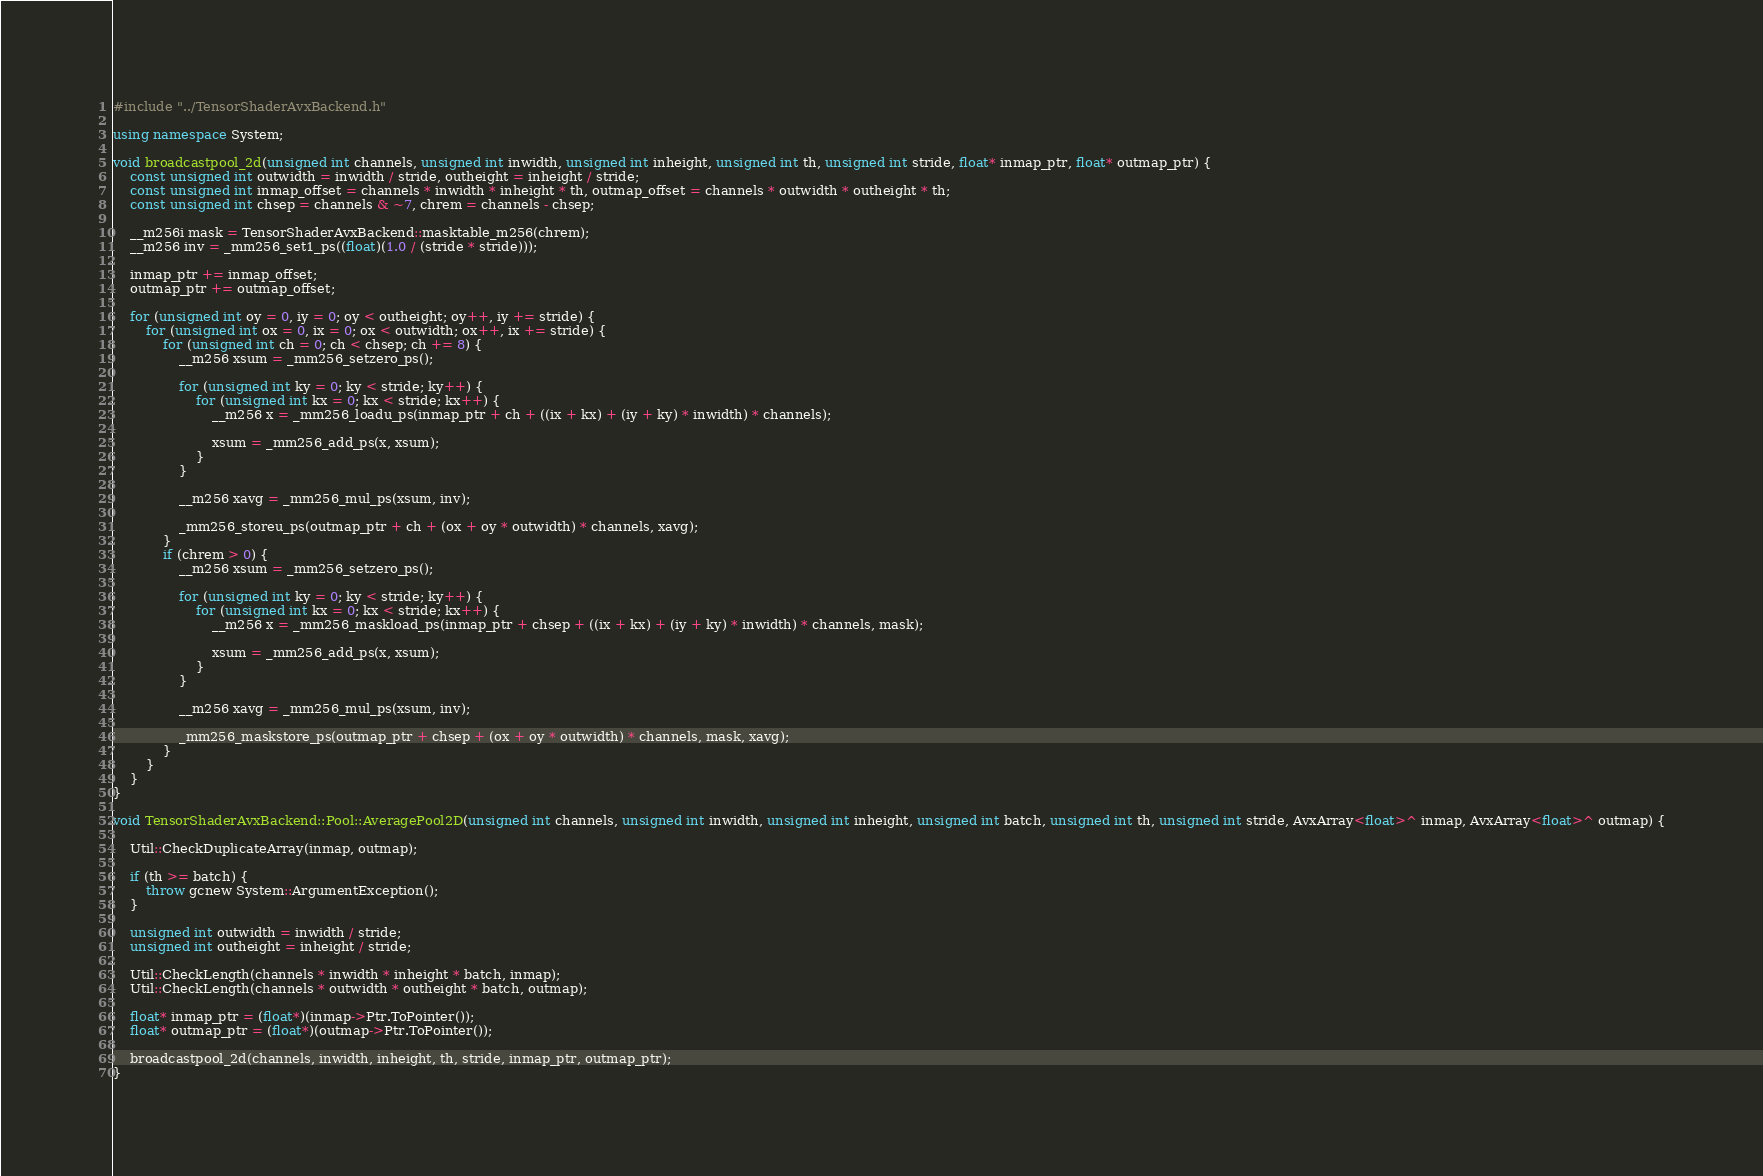<code> <loc_0><loc_0><loc_500><loc_500><_C++_>#include "../TensorShaderAvxBackend.h"

using namespace System;

void broadcastpool_2d(unsigned int channels, unsigned int inwidth, unsigned int inheight, unsigned int th, unsigned int stride, float* inmap_ptr, float* outmap_ptr) {
    const unsigned int outwidth = inwidth / stride, outheight = inheight / stride;
    const unsigned int inmap_offset = channels * inwidth * inheight * th, outmap_offset = channels * outwidth * outheight * th;
    const unsigned int chsep = channels & ~7, chrem = channels - chsep;

    __m256i mask = TensorShaderAvxBackend::masktable_m256(chrem);
    __m256 inv = _mm256_set1_ps((float)(1.0 / (stride * stride)));

    inmap_ptr += inmap_offset;
    outmap_ptr += outmap_offset;

    for (unsigned int oy = 0, iy = 0; oy < outheight; oy++, iy += stride) {
        for (unsigned int ox = 0, ix = 0; ox < outwidth; ox++, ix += stride) {
            for (unsigned int ch = 0; ch < chsep; ch += 8) {
                __m256 xsum = _mm256_setzero_ps();

                for (unsigned int ky = 0; ky < stride; ky++) {
                    for (unsigned int kx = 0; kx < stride; kx++) {
                        __m256 x = _mm256_loadu_ps(inmap_ptr + ch + ((ix + kx) + (iy + ky) * inwidth) * channels);

                        xsum = _mm256_add_ps(x, xsum);
                    }
                }

                __m256 xavg = _mm256_mul_ps(xsum, inv);

                _mm256_storeu_ps(outmap_ptr + ch + (ox + oy * outwidth) * channels, xavg);
            }
            if (chrem > 0) {
                __m256 xsum = _mm256_setzero_ps();

                for (unsigned int ky = 0; ky < stride; ky++) {
                    for (unsigned int kx = 0; kx < stride; kx++) {
                        __m256 x = _mm256_maskload_ps(inmap_ptr + chsep + ((ix + kx) + (iy + ky) * inwidth) * channels, mask);

                        xsum = _mm256_add_ps(x, xsum);
                    }
                }

                __m256 xavg = _mm256_mul_ps(xsum, inv);

                _mm256_maskstore_ps(outmap_ptr + chsep + (ox + oy * outwidth) * channels, mask, xavg);
            }
        }
    }
}

void TensorShaderAvxBackend::Pool::AveragePool2D(unsigned int channels, unsigned int inwidth, unsigned int inheight, unsigned int batch, unsigned int th, unsigned int stride, AvxArray<float>^ inmap, AvxArray<float>^ outmap) {

    Util::CheckDuplicateArray(inmap, outmap);

    if (th >= batch) {
        throw gcnew System::ArgumentException();
    }

    unsigned int outwidth = inwidth / stride;
    unsigned int outheight = inheight / stride;

    Util::CheckLength(channels * inwidth * inheight * batch, inmap);
    Util::CheckLength(channels * outwidth * outheight * batch, outmap);

    float* inmap_ptr = (float*)(inmap->Ptr.ToPointer());
    float* outmap_ptr = (float*)(outmap->Ptr.ToPointer());

    broadcastpool_2d(channels, inwidth, inheight, th, stride, inmap_ptr, outmap_ptr);
}
</code> 